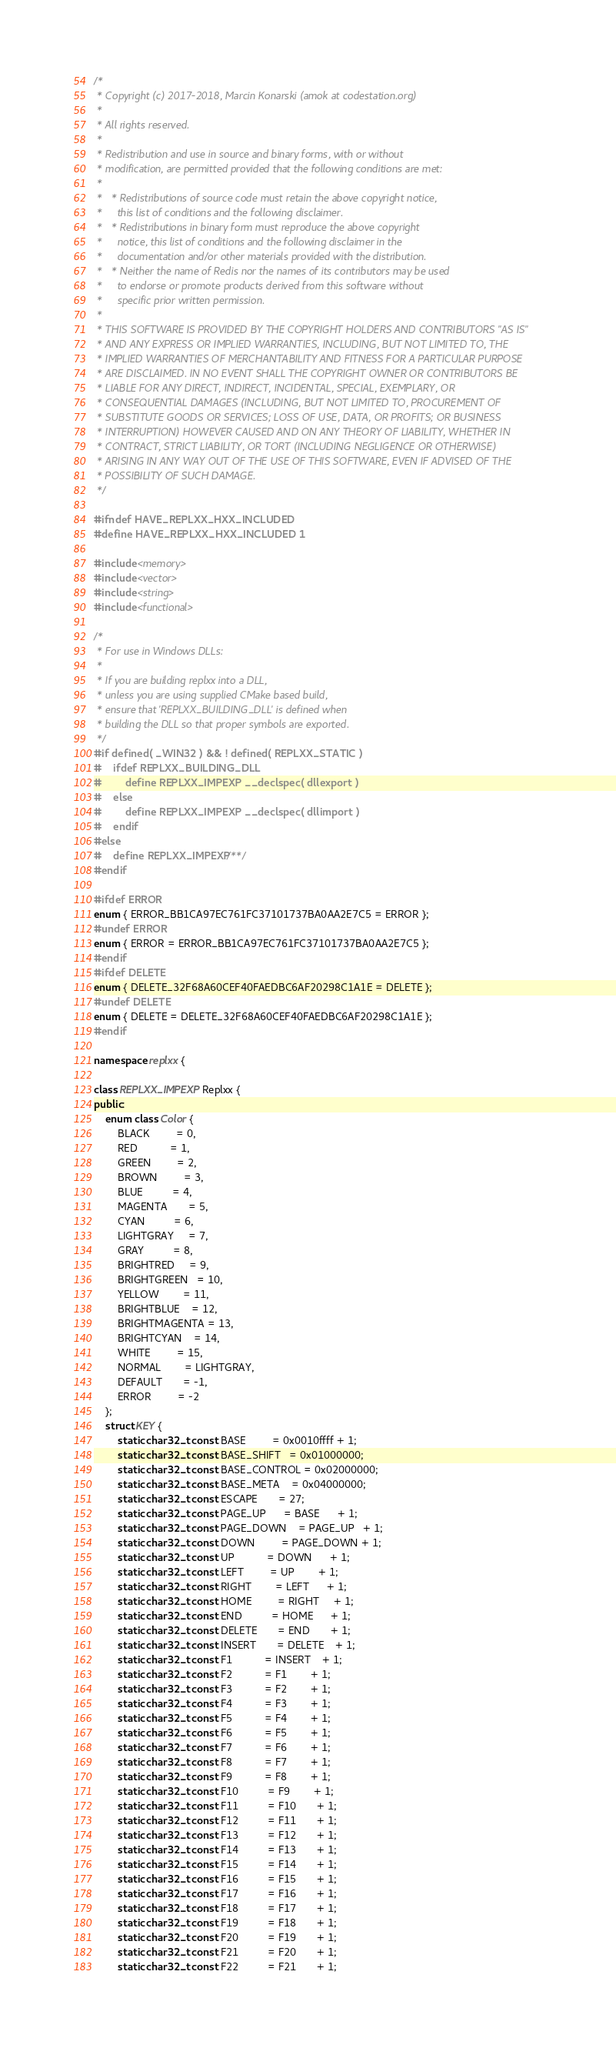Convert code to text. <code><loc_0><loc_0><loc_500><loc_500><_C++_>/*
 * Copyright (c) 2017-2018, Marcin Konarski (amok at codestation.org)
 *
 * All rights reserved.
 *
 * Redistribution and use in source and binary forms, with or without
 * modification, are permitted provided that the following conditions are met:
 *
 *   * Redistributions of source code must retain the above copyright notice,
 *     this list of conditions and the following disclaimer.
 *   * Redistributions in binary form must reproduce the above copyright
 *     notice, this list of conditions and the following disclaimer in the
 *     documentation and/or other materials provided with the distribution.
 *   * Neither the name of Redis nor the names of its contributors may be used
 *     to endorse or promote products derived from this software without
 *     specific prior written permission.
 *
 * THIS SOFTWARE IS PROVIDED BY THE COPYRIGHT HOLDERS AND CONTRIBUTORS "AS IS"
 * AND ANY EXPRESS OR IMPLIED WARRANTIES, INCLUDING, BUT NOT LIMITED TO, THE
 * IMPLIED WARRANTIES OF MERCHANTABILITY AND FITNESS FOR A PARTICULAR PURPOSE
 * ARE DISCLAIMED. IN NO EVENT SHALL THE COPYRIGHT OWNER OR CONTRIBUTORS BE
 * LIABLE FOR ANY DIRECT, INDIRECT, INCIDENTAL, SPECIAL, EXEMPLARY, OR
 * CONSEQUENTIAL DAMAGES (INCLUDING, BUT NOT LIMITED TO, PROCUREMENT OF
 * SUBSTITUTE GOODS OR SERVICES; LOSS OF USE, DATA, OR PROFITS; OR BUSINESS
 * INTERRUPTION) HOWEVER CAUSED AND ON ANY THEORY OF LIABILITY, WHETHER IN
 * CONTRACT, STRICT LIABILITY, OR TORT (INCLUDING NEGLIGENCE OR OTHERWISE)
 * ARISING IN ANY WAY OUT OF THE USE OF THIS SOFTWARE, EVEN IF ADVISED OF THE
 * POSSIBILITY OF SUCH DAMAGE.
 */

#ifndef HAVE_REPLXX_HXX_INCLUDED
#define HAVE_REPLXX_HXX_INCLUDED 1

#include <memory>
#include <vector>
#include <string>
#include <functional>

/*
 * For use in Windows DLLs:
 *
 * If you are building replxx into a DLL,
 * unless you are using supplied CMake based build,
 * ensure that 'REPLXX_BUILDING_DLL' is defined when
 * building the DLL so that proper symbols are exported.
 */
#if defined( _WIN32 ) && ! defined( REPLXX_STATIC )
#	ifdef REPLXX_BUILDING_DLL
#		define REPLXX_IMPEXP __declspec( dllexport )
#	else
#		define REPLXX_IMPEXP __declspec( dllimport )
#	endif
#else
#	define REPLXX_IMPEXP /**/
#endif

#ifdef ERROR
enum { ERROR_BB1CA97EC761FC37101737BA0AA2E7C5 = ERROR };
#undef ERROR
enum { ERROR = ERROR_BB1CA97EC761FC37101737BA0AA2E7C5 };
#endif
#ifdef DELETE
enum { DELETE_32F68A60CEF40FAEDBC6AF20298C1A1E = DELETE };
#undef DELETE
enum { DELETE = DELETE_32F68A60CEF40FAEDBC6AF20298C1A1E };
#endif

namespace replxx {

class REPLXX_IMPEXP Replxx {
public:
	enum class Color {
		BLACK         = 0,
		RED           = 1,
		GREEN         = 2,
		BROWN         = 3,
		BLUE          = 4,
		MAGENTA       = 5,
		CYAN          = 6,
		LIGHTGRAY     = 7,
		GRAY          = 8,
		BRIGHTRED     = 9,
		BRIGHTGREEN   = 10,
		YELLOW        = 11,
		BRIGHTBLUE    = 12,
		BRIGHTMAGENTA = 13,
		BRIGHTCYAN    = 14,
		WHITE         = 15,
		NORMAL        = LIGHTGRAY,
		DEFAULT       = -1,
		ERROR         = -2
	};
	struct KEY {
		static char32_t const BASE         = 0x0010ffff + 1;
		static char32_t const BASE_SHIFT   = 0x01000000;
		static char32_t const BASE_CONTROL = 0x02000000;
		static char32_t const BASE_META    = 0x04000000;
		static char32_t const ESCAPE       = 27;
		static char32_t const PAGE_UP      = BASE      + 1;
		static char32_t const PAGE_DOWN    = PAGE_UP   + 1;
		static char32_t const DOWN         = PAGE_DOWN + 1;
		static char32_t const UP           = DOWN      + 1;
		static char32_t const LEFT         = UP        + 1;
		static char32_t const RIGHT        = LEFT      + 1;
		static char32_t const HOME         = RIGHT     + 1;
		static char32_t const END          = HOME      + 1;
		static char32_t const DELETE       = END       + 1;
		static char32_t const INSERT       = DELETE    + 1;
		static char32_t const F1           = INSERT    + 1;
		static char32_t const F2           = F1        + 1;
		static char32_t const F3           = F2        + 1;
		static char32_t const F4           = F3        + 1;
		static char32_t const F5           = F4        + 1;
		static char32_t const F6           = F5        + 1;
		static char32_t const F7           = F6        + 1;
		static char32_t const F8           = F7        + 1;
		static char32_t const F9           = F8        + 1;
		static char32_t const F10          = F9        + 1;
		static char32_t const F11          = F10       + 1;
		static char32_t const F12          = F11       + 1;
		static char32_t const F13          = F12       + 1;
		static char32_t const F14          = F13       + 1;
		static char32_t const F15          = F14       + 1;
		static char32_t const F16          = F15       + 1;
		static char32_t const F17          = F16       + 1;
		static char32_t const F18          = F17       + 1;
		static char32_t const F19          = F18       + 1;
		static char32_t const F20          = F19       + 1;
		static char32_t const F21          = F20       + 1;
		static char32_t const F22          = F21       + 1;</code> 